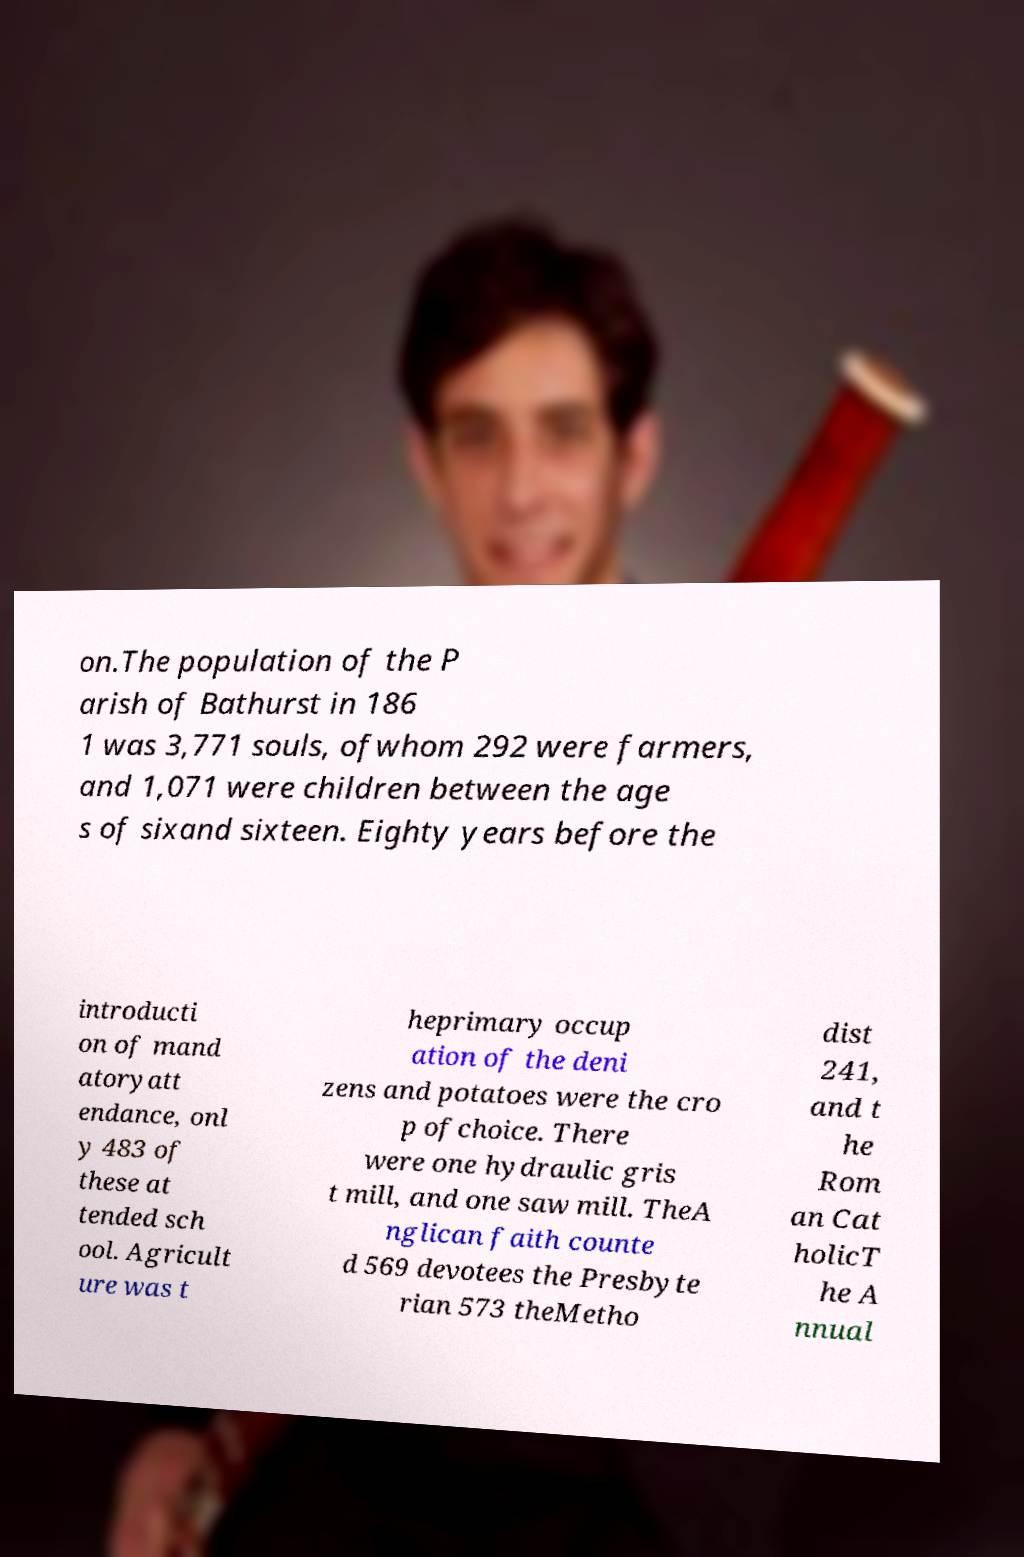Can you read and provide the text displayed in the image?This photo seems to have some interesting text. Can you extract and type it out for me? on.The population of the P arish of Bathurst in 186 1 was 3,771 souls, ofwhom 292 were farmers, and 1,071 were children between the age s of sixand sixteen. Eighty years before the introducti on of mand atoryatt endance, onl y 483 of these at tended sch ool. Agricult ure was t heprimary occup ation of the deni zens and potatoes were the cro p ofchoice. There were one hydraulic gris t mill, and one saw mill. TheA nglican faith counte d 569 devotees the Presbyte rian 573 theMetho dist 241, and t he Rom an Cat holicT he A nnual 